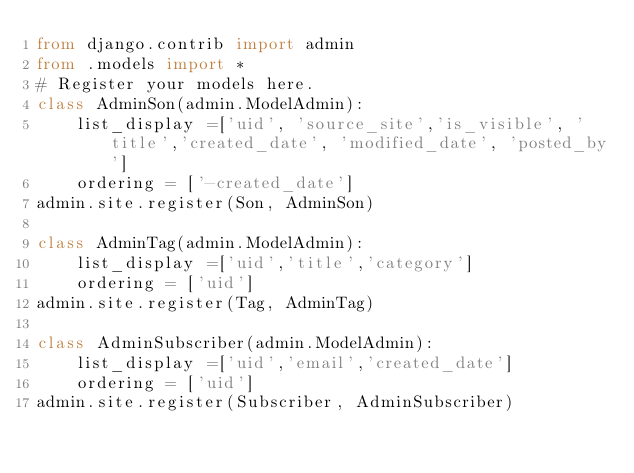Convert code to text. <code><loc_0><loc_0><loc_500><loc_500><_Python_>from django.contrib import admin
from .models import *
# Register your models here.
class AdminSon(admin.ModelAdmin):
    list_display =['uid', 'source_site','is_visible', 'title','created_date', 'modified_date', 'posted_by']
    ordering = ['-created_date']
admin.site.register(Son, AdminSon)

class AdminTag(admin.ModelAdmin):
    list_display =['uid','title','category']
    ordering = ['uid']
admin.site.register(Tag, AdminTag)

class AdminSubscriber(admin.ModelAdmin):
    list_display =['uid','email','created_date']
    ordering = ['uid']
admin.site.register(Subscriber, AdminSubscriber)</code> 